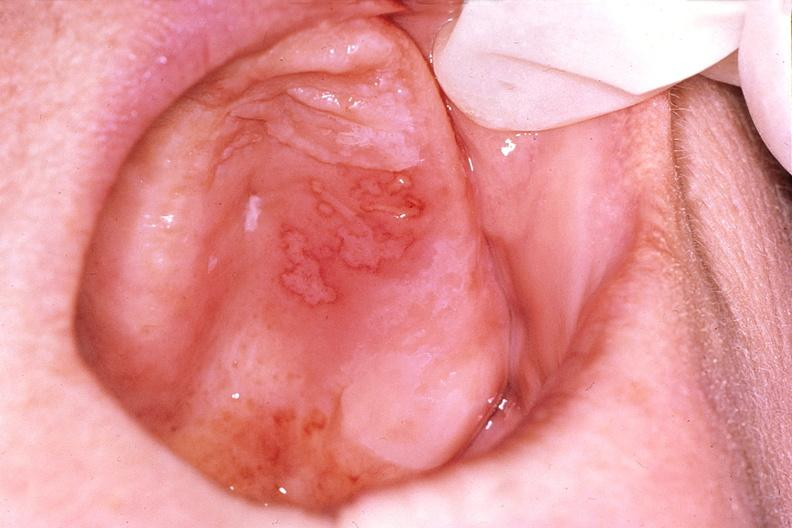s leiomyomas present?
Answer the question using a single word or phrase. No 